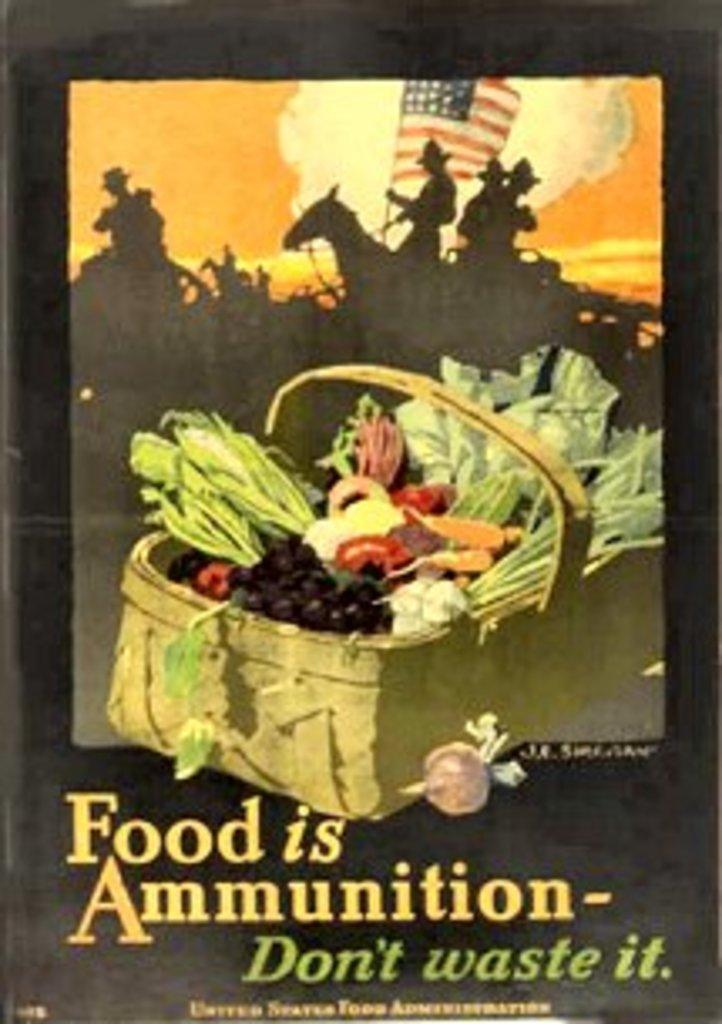<image>
Offer a succinct explanation of the picture presented. A poster with a basket of food reads,"Food is Ammunition." 